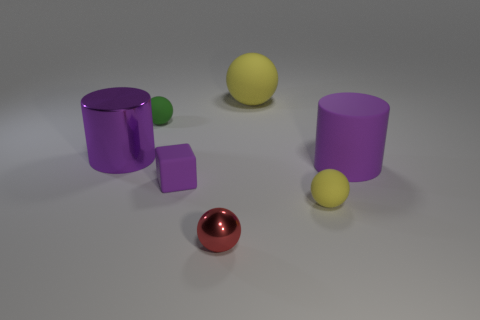There is a large cylinder that is behind the cylinder on the right side of the small red ball; what is its color?
Give a very brief answer. Purple. What is the large purple thing right of the large matte object on the left side of the tiny matte sphere that is on the right side of the big yellow matte sphere made of?
Ensure brevity in your answer.  Rubber. What number of gray metal blocks have the same size as the metal cylinder?
Provide a short and direct response. 0. There is a thing that is both behind the big purple metallic cylinder and left of the small purple cube; what is its material?
Your answer should be very brief. Rubber. What number of metal cylinders are to the right of the large purple shiny thing?
Provide a succinct answer. 0. There is a tiny metallic thing; is its shape the same as the yellow object that is to the right of the big sphere?
Make the answer very short. Yes. Is there a large purple object of the same shape as the big yellow matte object?
Offer a very short reply. No. What is the shape of the tiny rubber object that is on the right side of the metal thing in front of the rubber cube?
Offer a terse response. Sphere. The big purple object that is to the right of the tiny metal ball has what shape?
Give a very brief answer. Cylinder. Do the large rubber object that is right of the small yellow ball and the tiny rubber ball that is to the right of the small red metal object have the same color?
Give a very brief answer. No. 